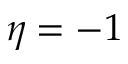Convert formula to latex. <formula><loc_0><loc_0><loc_500><loc_500>\eta = - 1</formula> 